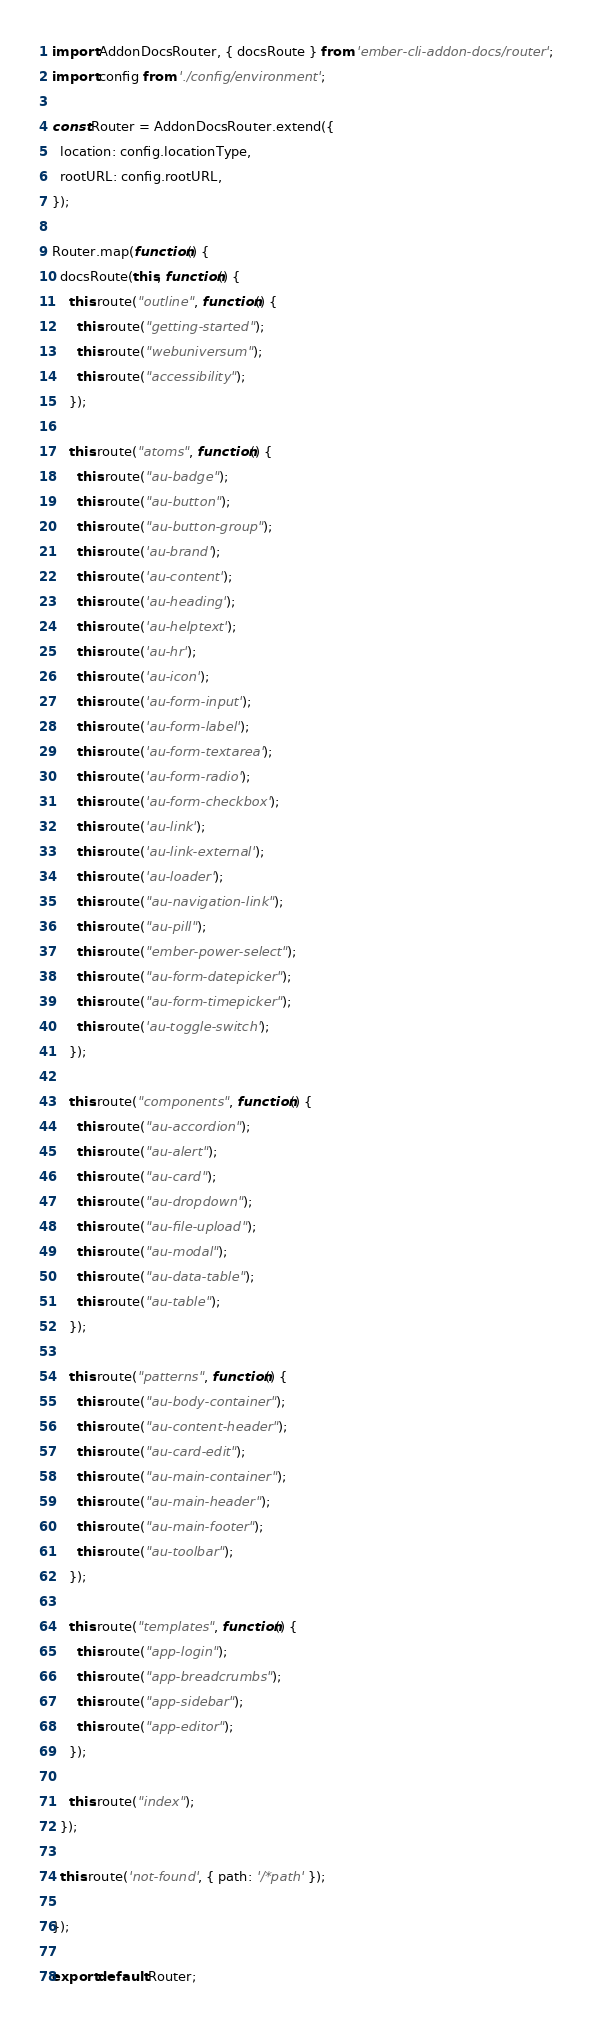Convert code to text. <code><loc_0><loc_0><loc_500><loc_500><_JavaScript_>import AddonDocsRouter, { docsRoute } from 'ember-cli-addon-docs/router';
import config from './config/environment';

const Router = AddonDocsRouter.extend({
  location: config.locationType,
  rootURL: config.rootURL,
});

Router.map(function() {
  docsRoute(this, function() {
    this.route("outline", function() {
      this.route("getting-started");
      this.route("webuniversum");
      this.route("accessibility");
    });

    this.route("atoms", function() {
      this.route("au-badge");
      this.route("au-button");
      this.route("au-button-group");
      this.route('au-brand');
      this.route('au-content');
      this.route('au-heading');
      this.route('au-helptext');
      this.route('au-hr');
      this.route('au-icon');
      this.route('au-form-input');
      this.route('au-form-label');
      this.route('au-form-textarea');
      this.route('au-form-radio');
      this.route('au-form-checkbox');
      this.route('au-link');
      this.route('au-link-external');
      this.route('au-loader');
      this.route("au-navigation-link");
      this.route("au-pill");
      this.route("ember-power-select");
      this.route("au-form-datepicker");
      this.route("au-form-timepicker");
      this.route('au-toggle-switch');
    });

    this.route("components", function() {
      this.route("au-accordion");
      this.route("au-alert");
      this.route("au-card");
      this.route("au-dropdown");
      this.route("au-file-upload");
      this.route("au-modal");
      this.route("au-data-table");
      this.route("au-table");
    });

    this.route("patterns", function() {
      this.route("au-body-container");
      this.route("au-content-header");
      this.route("au-card-edit");
      this.route("au-main-container");
      this.route("au-main-header");
      this.route("au-main-footer");
      this.route("au-toolbar");
    });

    this.route("templates", function() {
      this.route("app-login");
      this.route("app-breadcrumbs");
      this.route("app-sidebar");
      this.route("app-editor");
    });

    this.route("index");
  });

  this.route('not-found', { path: '/*path' });

});

export default Router;
</code> 